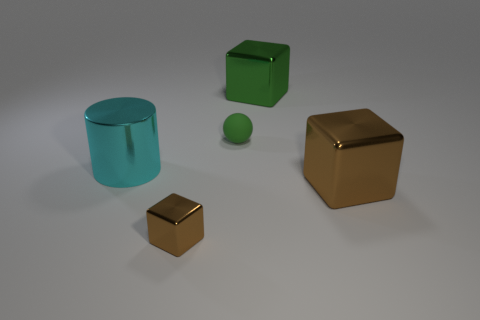Can you tell me about the lighting in the scene? Certainly, the lighting in the scene is soft and diffused, suggesting an indirect light source. There are gentle shadows cast by the objects onto the ground, indicating the light is coming from above. The reflections on the shiny surfaces, particularly on the gold-toned cube and cylinder, reveal a well-lit environment that accentuates their metallic luster. 